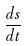Convert formula to latex. <formula><loc_0><loc_0><loc_500><loc_500>\frac { d s } { d t }</formula> 